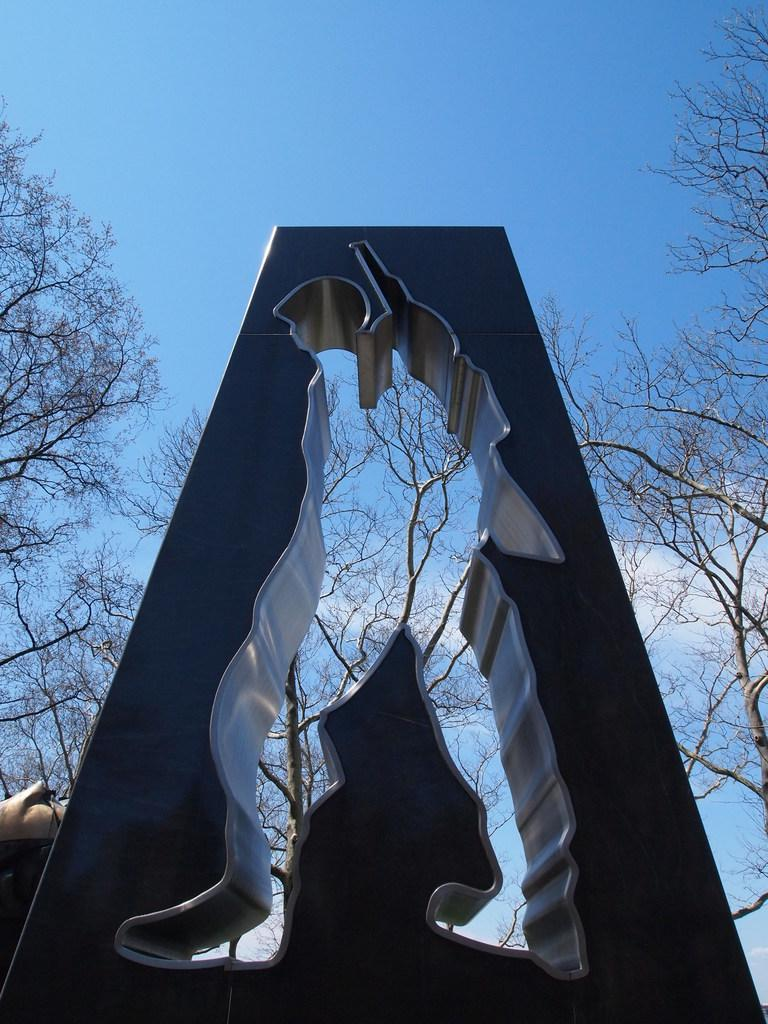What is located in the center of the image? There is a wall in the center of the image. What type of vegetation can be seen in the image? There are trees in the image. What is visible in the background of the image? The sky is visible in the background of the image. How many coils can be seen in the image? There are no coils present in the image. What type of snakes are slithering through the trees in the image? There are no snakes present in the image; it only features trees and a wall. 